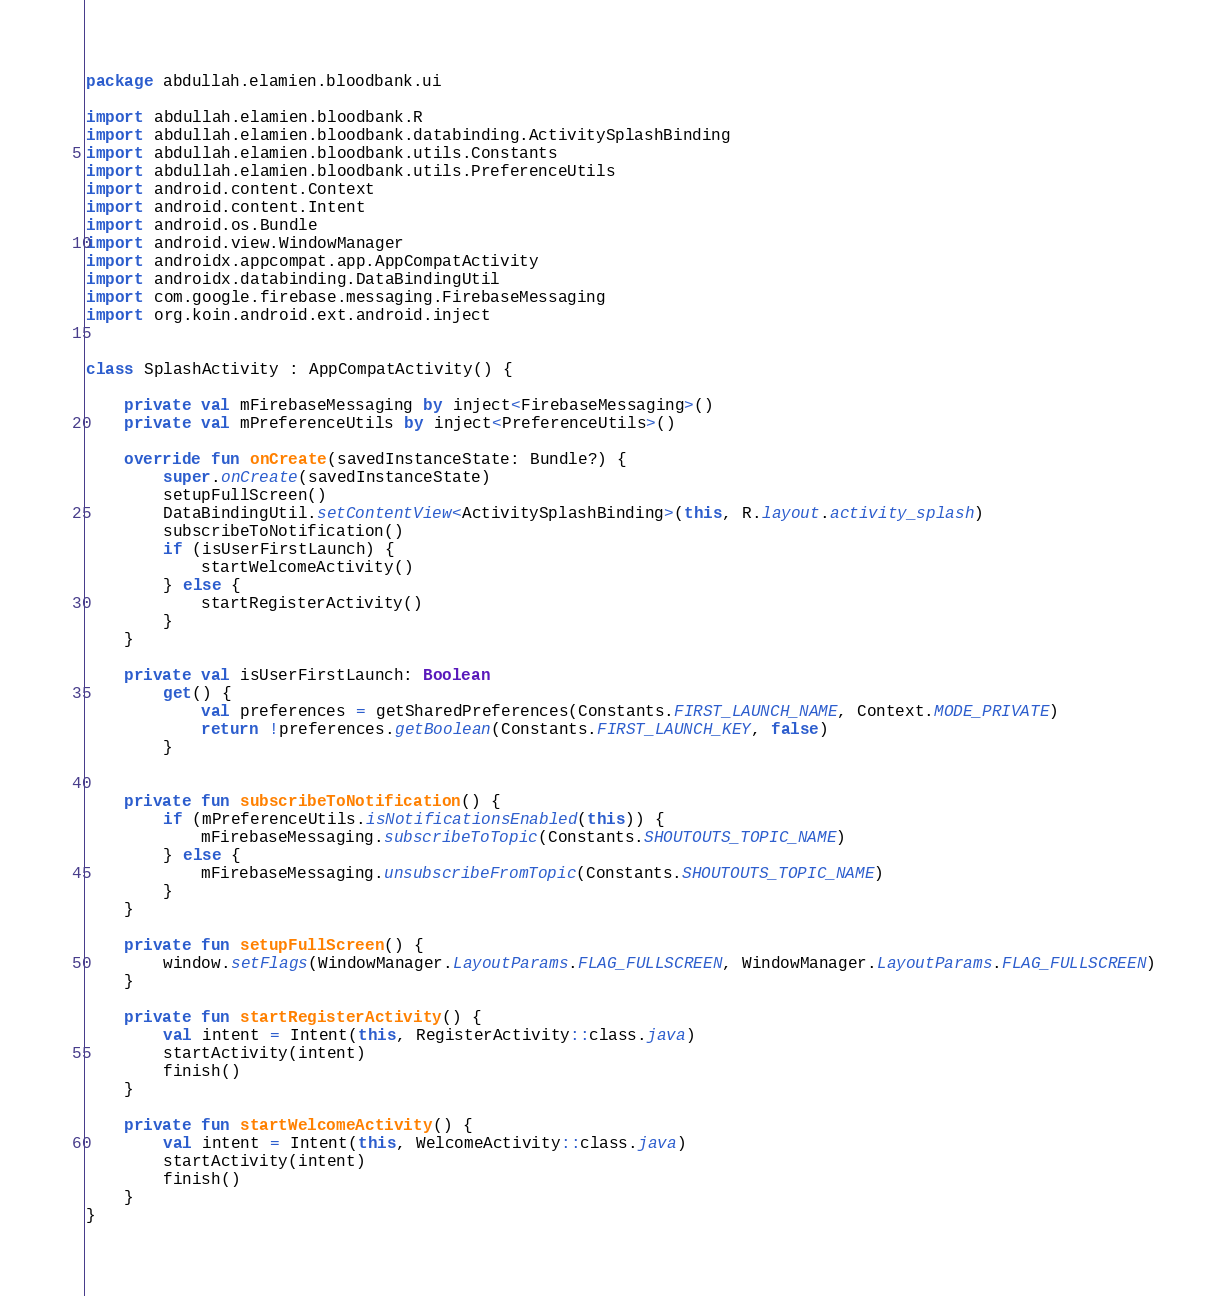Convert code to text. <code><loc_0><loc_0><loc_500><loc_500><_Kotlin_>package abdullah.elamien.bloodbank.ui

import abdullah.elamien.bloodbank.R
import abdullah.elamien.bloodbank.databinding.ActivitySplashBinding
import abdullah.elamien.bloodbank.utils.Constants
import abdullah.elamien.bloodbank.utils.PreferenceUtils
import android.content.Context
import android.content.Intent
import android.os.Bundle
import android.view.WindowManager
import androidx.appcompat.app.AppCompatActivity
import androidx.databinding.DataBindingUtil
import com.google.firebase.messaging.FirebaseMessaging
import org.koin.android.ext.android.inject


class SplashActivity : AppCompatActivity() {

    private val mFirebaseMessaging by inject<FirebaseMessaging>()
    private val mPreferenceUtils by inject<PreferenceUtils>()

    override fun onCreate(savedInstanceState: Bundle?) {
        super.onCreate(savedInstanceState)
        setupFullScreen()
        DataBindingUtil.setContentView<ActivitySplashBinding>(this, R.layout.activity_splash)
        subscribeToNotification()
        if (isUserFirstLaunch) {
            startWelcomeActivity()
        } else {
            startRegisterActivity()
        }
    }

    private val isUserFirstLaunch: Boolean
        get() {
            val preferences = getSharedPreferences(Constants.FIRST_LAUNCH_NAME, Context.MODE_PRIVATE)
            return !preferences.getBoolean(Constants.FIRST_LAUNCH_KEY, false)
        }


    private fun subscribeToNotification() {
        if (mPreferenceUtils.isNotificationsEnabled(this)) {
            mFirebaseMessaging.subscribeToTopic(Constants.SHOUTOUTS_TOPIC_NAME)
        } else {
            mFirebaseMessaging.unsubscribeFromTopic(Constants.SHOUTOUTS_TOPIC_NAME)
        }
    }

    private fun setupFullScreen() {
        window.setFlags(WindowManager.LayoutParams.FLAG_FULLSCREEN, WindowManager.LayoutParams.FLAG_FULLSCREEN)
    }

    private fun startRegisterActivity() {
        val intent = Intent(this, RegisterActivity::class.java)
        startActivity(intent)
        finish()
    }

    private fun startWelcomeActivity() {
        val intent = Intent(this, WelcomeActivity::class.java)
        startActivity(intent)
        finish()
    }
}
</code> 